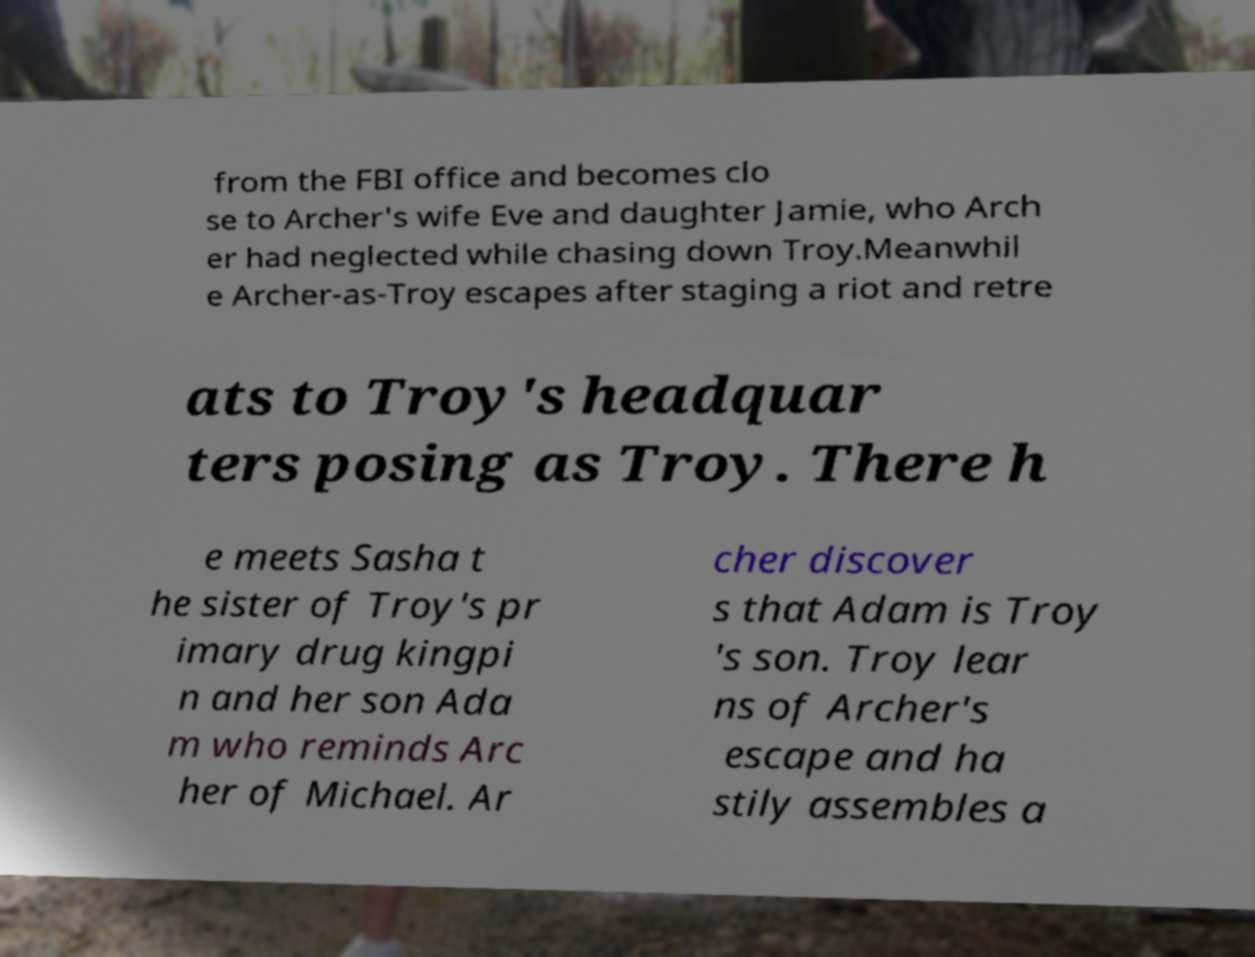I need the written content from this picture converted into text. Can you do that? from the FBI office and becomes clo se to Archer's wife Eve and daughter Jamie, who Arch er had neglected while chasing down Troy.Meanwhil e Archer-as-Troy escapes after staging a riot and retre ats to Troy's headquar ters posing as Troy. There h e meets Sasha t he sister of Troy's pr imary drug kingpi n and her son Ada m who reminds Arc her of Michael. Ar cher discover s that Adam is Troy 's son. Troy lear ns of Archer's escape and ha stily assembles a 